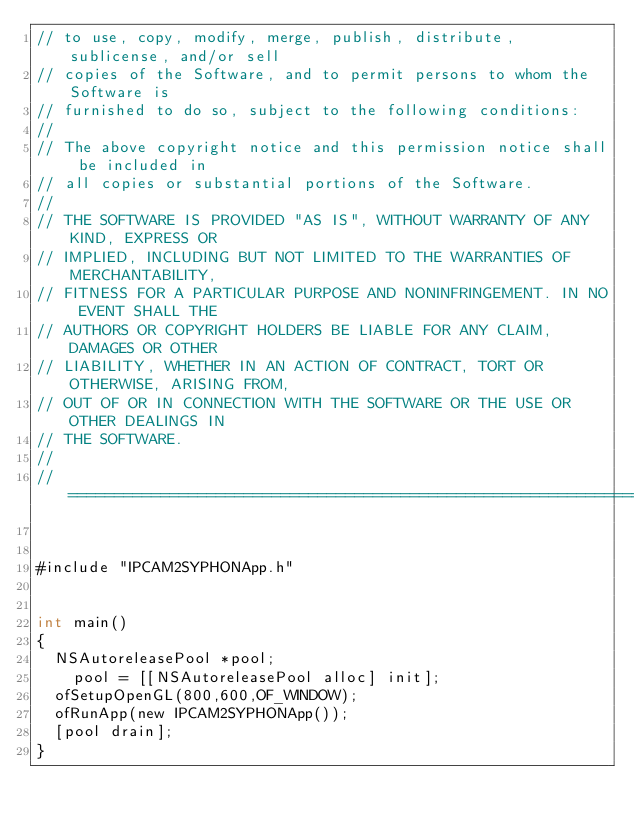Convert code to text. <code><loc_0><loc_0><loc_500><loc_500><_ObjectiveC_>// to use, copy, modify, merge, publish, distribute, sublicense, and/or sell
// copies of the Software, and to permit persons to whom the Software is
// furnished to do so, subject to the following conditions:
//
// The above copyright notice and this permission notice shall be included in
// all copies or substantial portions of the Software.
//
// THE SOFTWARE IS PROVIDED "AS IS", WITHOUT WARRANTY OF ANY KIND, EXPRESS OR
// IMPLIED, INCLUDING BUT NOT LIMITED TO THE WARRANTIES OF MERCHANTABILITY,
// FITNESS FOR A PARTICULAR PURPOSE AND NONINFRINGEMENT. IN NO EVENT SHALL THE
// AUTHORS OR COPYRIGHT HOLDERS BE LIABLE FOR ANY CLAIM, DAMAGES OR OTHER
// LIABILITY, WHETHER IN AN ACTION OF CONTRACT, TORT OR OTHERWISE, ARISING FROM,
// OUT OF OR IN CONNECTION WITH THE SOFTWARE OR THE USE OR OTHER DEALINGS IN
// THE SOFTWARE.
//
// =============================================================================


#include "IPCAM2SYPHONApp.h"


int main()
{
	NSAutoreleasePool *pool;
    pool = [[NSAutoreleasePool alloc] init];
	ofSetupOpenGL(800,600,OF_WINDOW);
	ofRunApp(new IPCAM2SYPHONApp());
	[pool drain];
}
</code> 